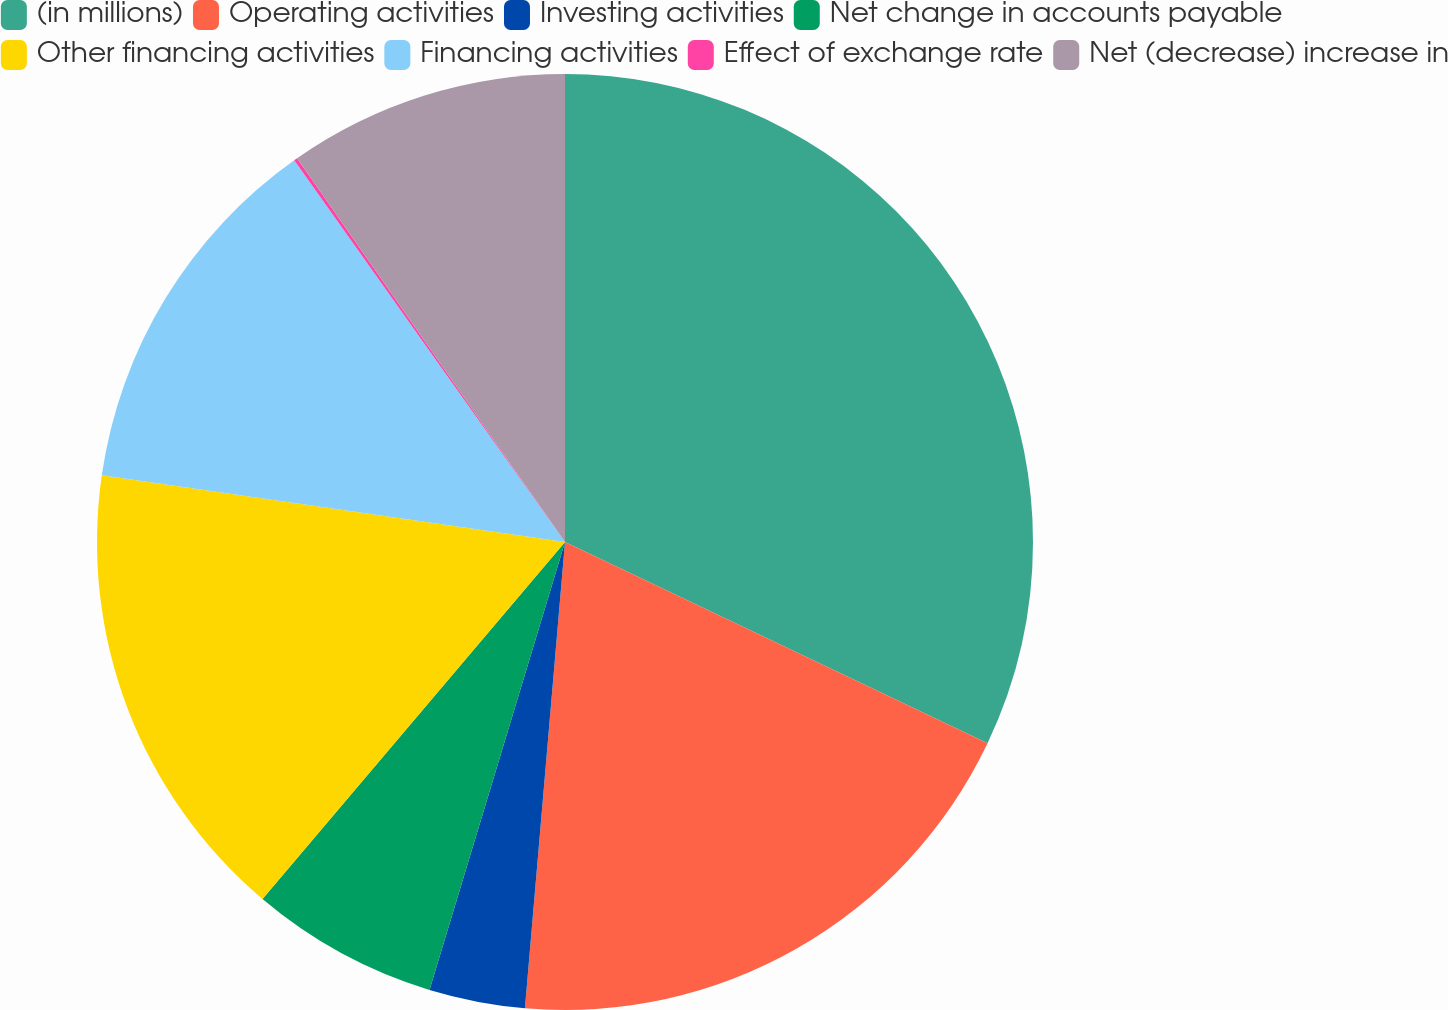<chart> <loc_0><loc_0><loc_500><loc_500><pie_chart><fcel>(in millions)<fcel>Operating activities<fcel>Investing activities<fcel>Net change in accounts payable<fcel>Other financing activities<fcel>Financing activities<fcel>Effect of exchange rate<fcel>Net (decrease) increase in<nl><fcel>32.07%<fcel>19.29%<fcel>3.31%<fcel>6.51%<fcel>16.09%<fcel>12.9%<fcel>0.12%<fcel>9.7%<nl></chart> 